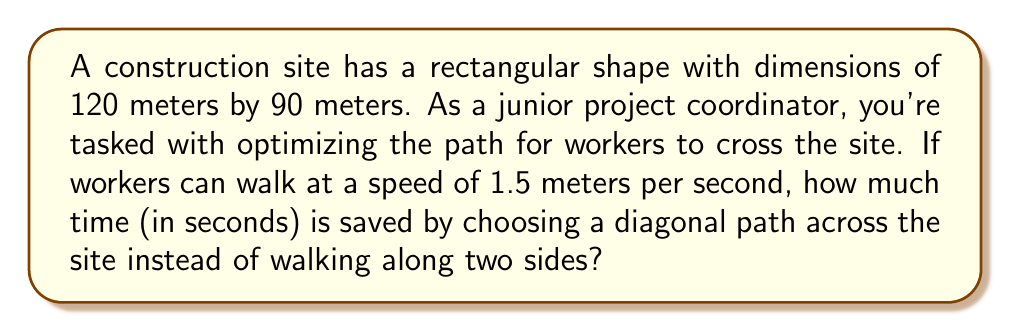Teach me how to tackle this problem. Let's approach this step-by-step:

1. Calculate the distance along the two sides:
   $$d_{sides} = 120 + 90 = 210 \text{ meters}$$

2. Calculate the diagonal distance using the Pythagorean theorem:
   $$d_{diagonal} = \sqrt{120^2 + 90^2} = \sqrt{14400 + 8100} = \sqrt{22500} = 150 \text{ meters}$$

3. Calculate the time taken to walk along the sides:
   $$t_{sides} = \frac{d_{sides}}{speed} = \frac{210}{1.5} = 140 \text{ seconds}$$

4. Calculate the time taken to walk along the diagonal:
   $$t_{diagonal} = \frac{d_{diagonal}}{speed} = \frac{150}{1.5} = 100 \text{ seconds}$$

5. Calculate the time saved:
   $$t_{saved} = t_{sides} - t_{diagonal} = 140 - 100 = 40 \text{ seconds}$$

[asy]
import geometry;

size(200);
pair A = (0,0), B = (120,0), C = (120,90), D = (0,90);
draw(A--B--C--D--cycle);
draw(A--C, dashed);

label("120m", (60,0), S);
label("90m", (120,45), E);
label("Diagonal", (60,45), NW);
[/asy]

This diagram illustrates the rectangular construction site and the diagonal path.
Answer: 40 seconds 